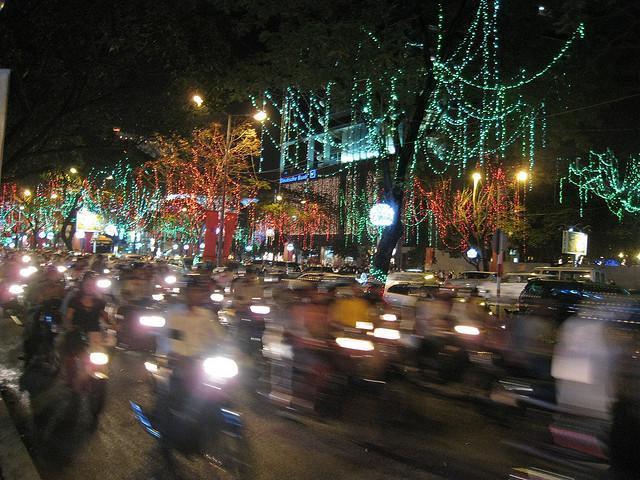How many moving lanes of traffic are there?
Give a very brief answer. 4. How many motorcycles are visible?
Give a very brief answer. 4. How many people can you see?
Give a very brief answer. 5. 